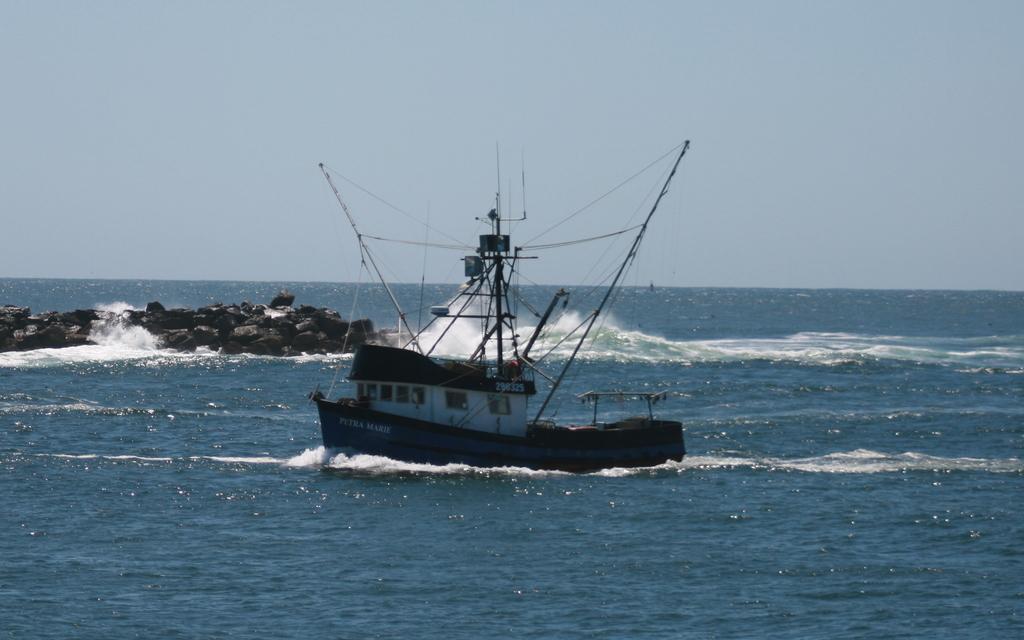Describe this image in one or two sentences. In this image there is a boat on a sea and there are rocks, in the background there is the sky. 